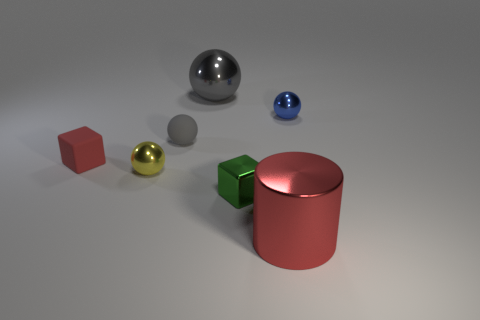What material is the object that is the same color as the metal cylinder?
Offer a terse response. Rubber. What is the material of the big thing that is right of the gray object behind the gray thing on the left side of the gray metallic sphere?
Provide a succinct answer. Metal. Is the tiny red block made of the same material as the green thing in front of the small yellow ball?
Give a very brief answer. No. What material is the tiny yellow thing that is the same shape as the blue shiny object?
Your response must be concise. Metal. Are there more small gray objects that are behind the small matte sphere than small rubber blocks that are right of the large red metallic thing?
Ensure brevity in your answer.  No. There is a blue object that is the same material as the small yellow ball; what is its shape?
Ensure brevity in your answer.  Sphere. How many other objects are there of the same shape as the large red thing?
Provide a short and direct response. 0. There is a big metal thing that is behind the tiny yellow shiny sphere; what is its shape?
Provide a succinct answer. Sphere. The cylinder has what color?
Provide a short and direct response. Red. How many other things are there of the same size as the red metal cylinder?
Make the answer very short. 1. 